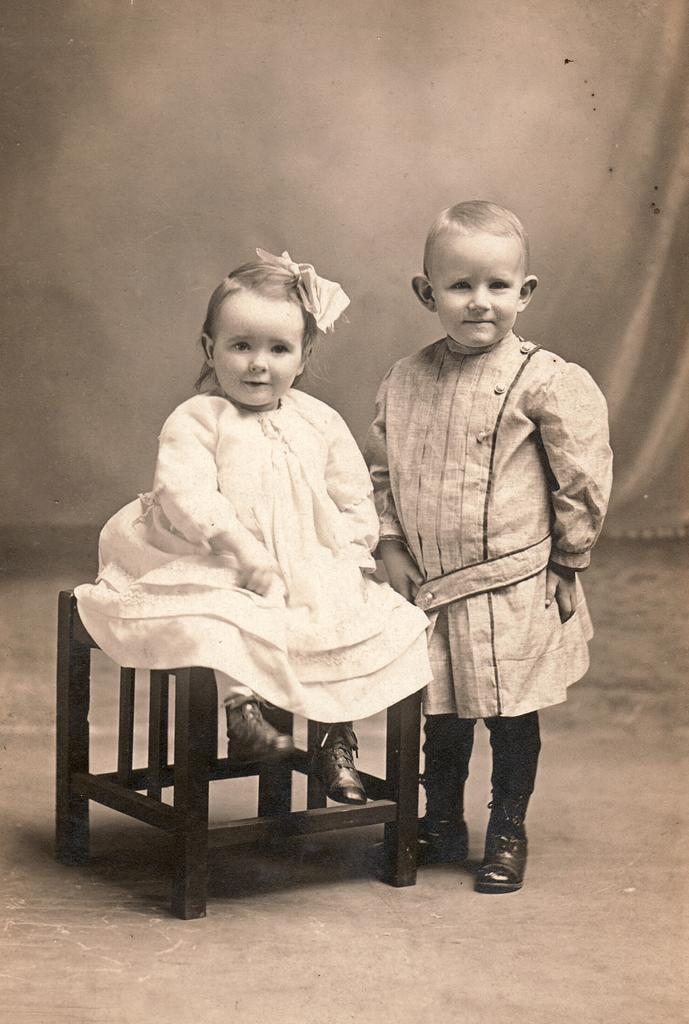What are the main subjects in the image? There is a small girl and a boy in the image. What can be said about the color scheme of the image? The image is black and white. Can you see an airplane flying in the background of the image? There is no airplane visible in the image. Is there a mine visible in the image? There is no mine present in the image. Is there any sleet falling in the image? There is no indication of sleet in the image. 